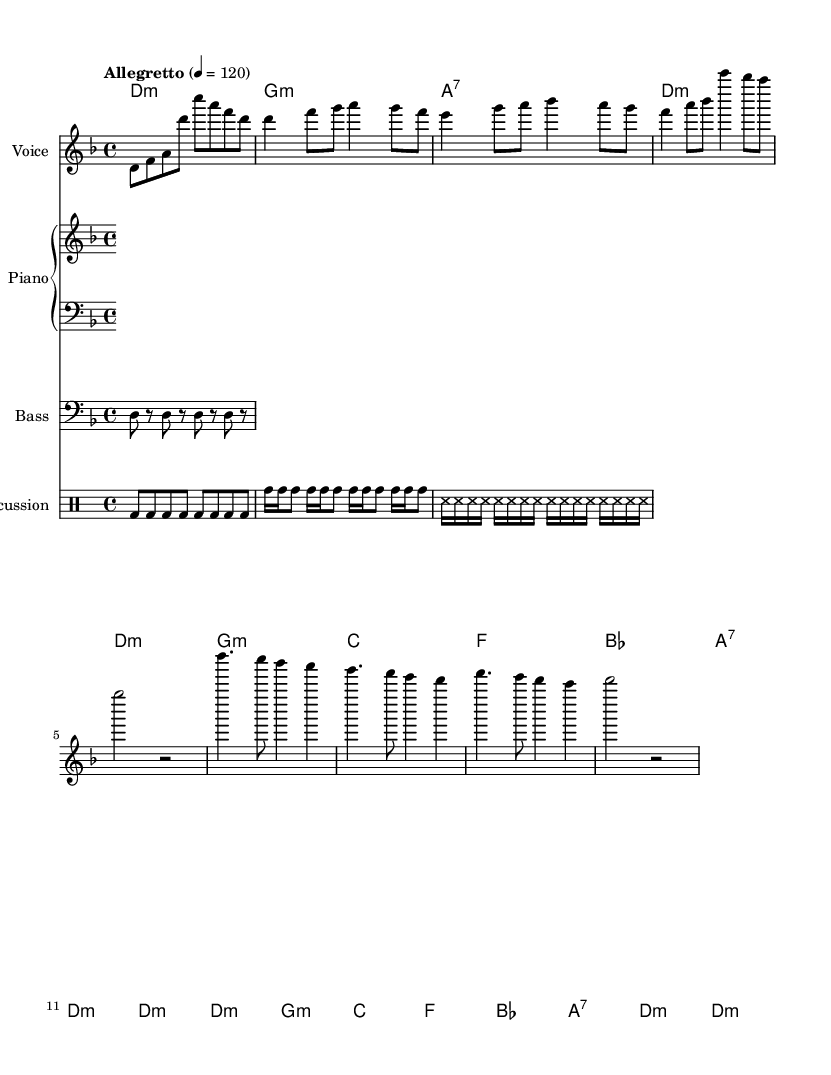What is the key signature of this music? The key signature is indicated by the number of sharps or flats at the beginning of the staff. In this piece, there is one flat, which corresponds to the key of D minor.
Answer: D minor What is the time signature of this music? The time signature is located at the beginning of the piece after the key signature. It is represented as a fraction, and in this case, it shows 4 over 4, indicating four beats per measure.
Answer: 4/4 What is the tempo marking of this music? The tempo marking is found partway through the score and is indicated as "Allegretto" followed by a metronome marking (4 = 120). This indicates the speed of the piece.
Answer: Allegretto, 120 How many measures are in the verse section? By counting the measures from the start of the verse until the transition to the chorus, there are 8 measures in this section of the song.
Answer: 8 What is the main theme addressed in the lyrics? Analyzing the lyrics reveals that the main theme relates to social and cultural change, emphasizing roots, identity, and learning from the past which reflects anthropological issues.
Answer: Social and cultural identity What percussion instruments are used in the score? The score explicitly includes parts for different percussion instruments, in this case, it mentions "bd" for bass drum, "tomh" for toms, and "ss" for shaker, indicating these instruments are featured in the arrangement.
Answer: Conga, bongos, shaker 